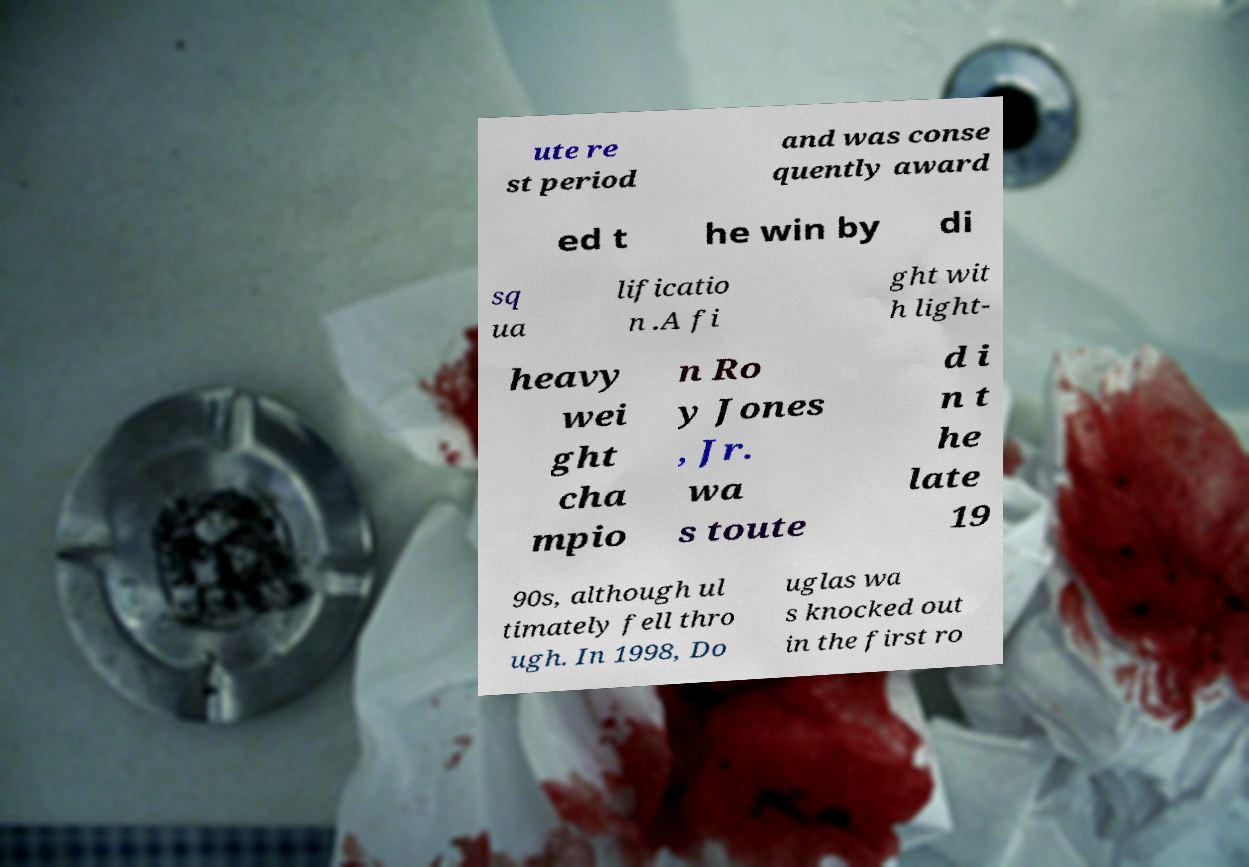Can you accurately transcribe the text from the provided image for me? ute re st period and was conse quently award ed t he win by di sq ua lificatio n .A fi ght wit h light- heavy wei ght cha mpio n Ro y Jones , Jr. wa s toute d i n t he late 19 90s, although ul timately fell thro ugh. In 1998, Do uglas wa s knocked out in the first ro 